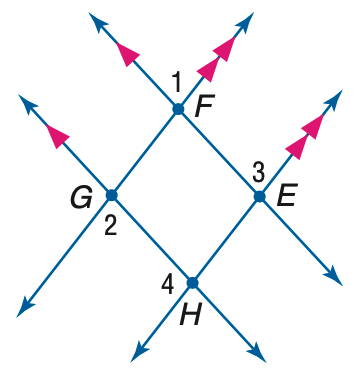Question: If m \angle 1 = 3 x + 40, m \angle 2 = 2(y - 10), and m \angle 3 = 2 x + 70, find y.
Choices:
A. 55
B. 60
C. 65
D. 75
Answer with the letter. Answer: D 